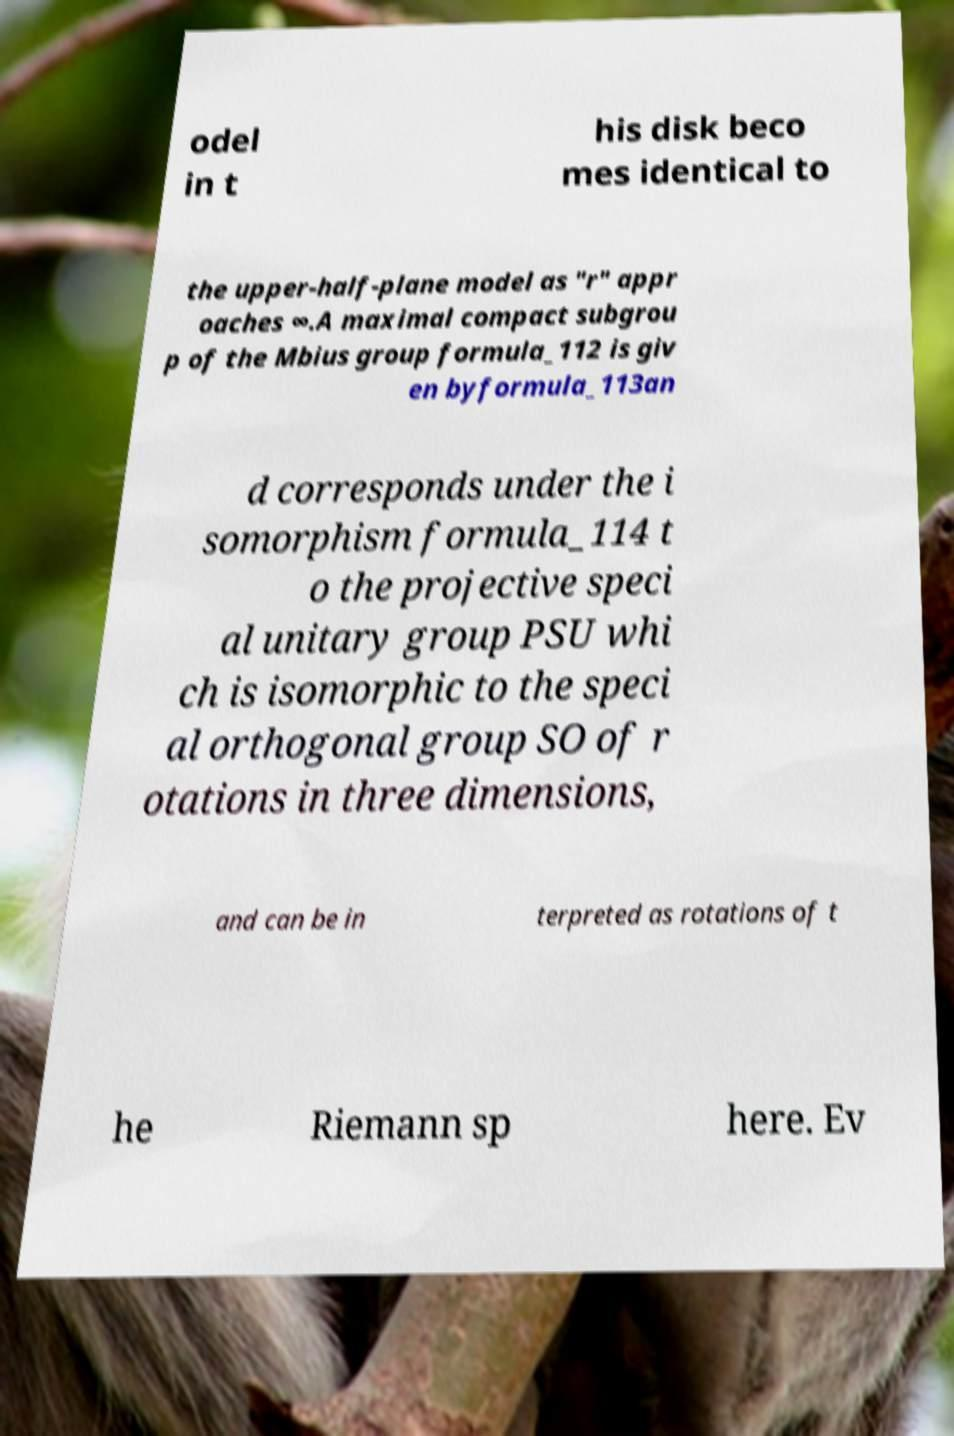There's text embedded in this image that I need extracted. Can you transcribe it verbatim? odel in t his disk beco mes identical to the upper-half-plane model as "r" appr oaches ∞.A maximal compact subgrou p of the Mbius group formula_112 is giv en byformula_113an d corresponds under the i somorphism formula_114 t o the projective speci al unitary group PSU whi ch is isomorphic to the speci al orthogonal group SO of r otations in three dimensions, and can be in terpreted as rotations of t he Riemann sp here. Ev 